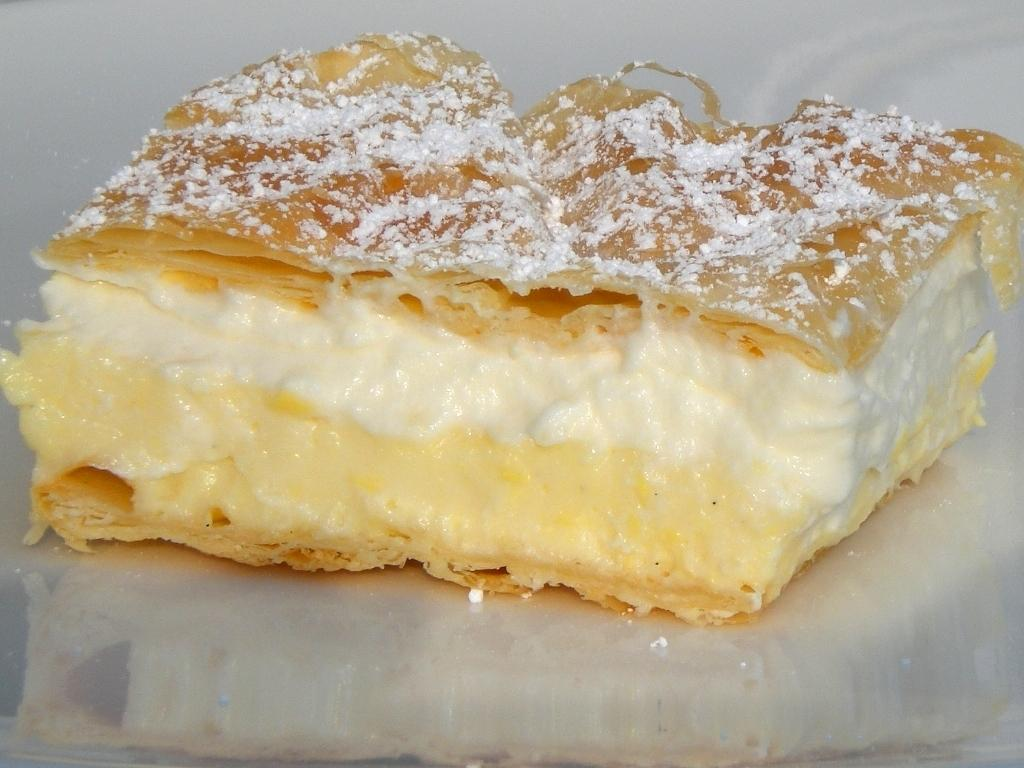What is the main subject of the image? The main subject of the image is a piece of cake. Where is the piece of cake located? The piece of cake is on a surface. What type of art is being created with the force of wool in the image? There is no art, force, or wool present in the image; it features a piece of cake on a surface. 